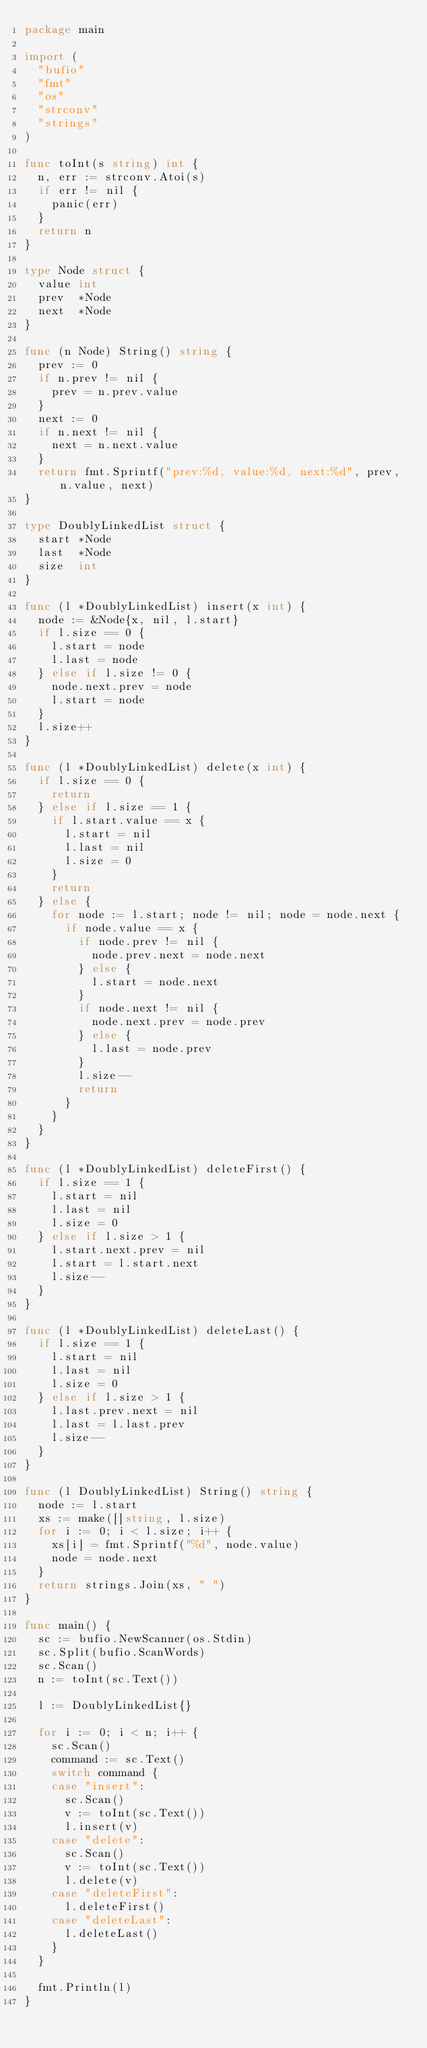<code> <loc_0><loc_0><loc_500><loc_500><_Go_>package main

import (
	"bufio"
	"fmt"
	"os"
	"strconv"
	"strings"
)

func toInt(s string) int {
	n, err := strconv.Atoi(s)
	if err != nil {
		panic(err)
	}
	return n
}

type Node struct {
	value int
	prev  *Node
	next  *Node
}

func (n Node) String() string {
	prev := 0
	if n.prev != nil {
		prev = n.prev.value
	}
	next := 0
	if n.next != nil {
		next = n.next.value
	}
	return fmt.Sprintf("prev:%d, value:%d, next:%d", prev, n.value, next)
}

type DoublyLinkedList struct {
	start *Node
	last  *Node
	size  int
}

func (l *DoublyLinkedList) insert(x int) {
	node := &Node{x, nil, l.start}
	if l.size == 0 {
		l.start = node
		l.last = node
	} else if l.size != 0 {
		node.next.prev = node
		l.start = node
	}
	l.size++
}

func (l *DoublyLinkedList) delete(x int) {
	if l.size == 0 {
		return
	} else if l.size == 1 {
		if l.start.value == x {
			l.start = nil
			l.last = nil
			l.size = 0
		}
		return
	} else {
		for node := l.start; node != nil; node = node.next {
			if node.value == x {
				if node.prev != nil {
					node.prev.next = node.next
				} else {
					l.start = node.next
				}
				if node.next != nil {
					node.next.prev = node.prev
				} else {
					l.last = node.prev
				}
				l.size--
				return
			}
		}
	}
}

func (l *DoublyLinkedList) deleteFirst() {
	if l.size == 1 {
		l.start = nil
		l.last = nil
		l.size = 0
	} else if l.size > 1 {
		l.start.next.prev = nil
		l.start = l.start.next
		l.size--
	}
}

func (l *DoublyLinkedList) deleteLast() {
	if l.size == 1 {
		l.start = nil
		l.last = nil
		l.size = 0
	} else if l.size > 1 {
		l.last.prev.next = nil
		l.last = l.last.prev
		l.size--
	}
}

func (l DoublyLinkedList) String() string {
	node := l.start
	xs := make([]string, l.size)
	for i := 0; i < l.size; i++ {
		xs[i] = fmt.Sprintf("%d", node.value)
		node = node.next
	}
	return strings.Join(xs, " ")
}

func main() {
	sc := bufio.NewScanner(os.Stdin)
	sc.Split(bufio.ScanWords)
	sc.Scan()
	n := toInt(sc.Text())

	l := DoublyLinkedList{}

	for i := 0; i < n; i++ {
		sc.Scan()
		command := sc.Text()
		switch command {
		case "insert":
			sc.Scan()
			v := toInt(sc.Text())
			l.insert(v)
		case "delete":
			sc.Scan()
			v := toInt(sc.Text())
			l.delete(v)
		case "deleteFirst":
			l.deleteFirst()
		case "deleteLast":
			l.deleteLast()
		}
	}

	fmt.Println(l)
}

</code> 